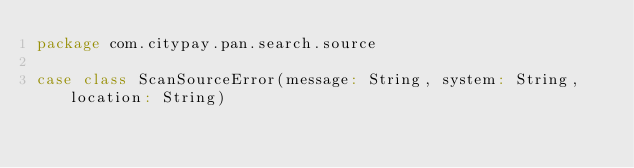Convert code to text. <code><loc_0><loc_0><loc_500><loc_500><_Scala_>package com.citypay.pan.search.source

case class ScanSourceError(message: String, system: String, location: String)</code> 